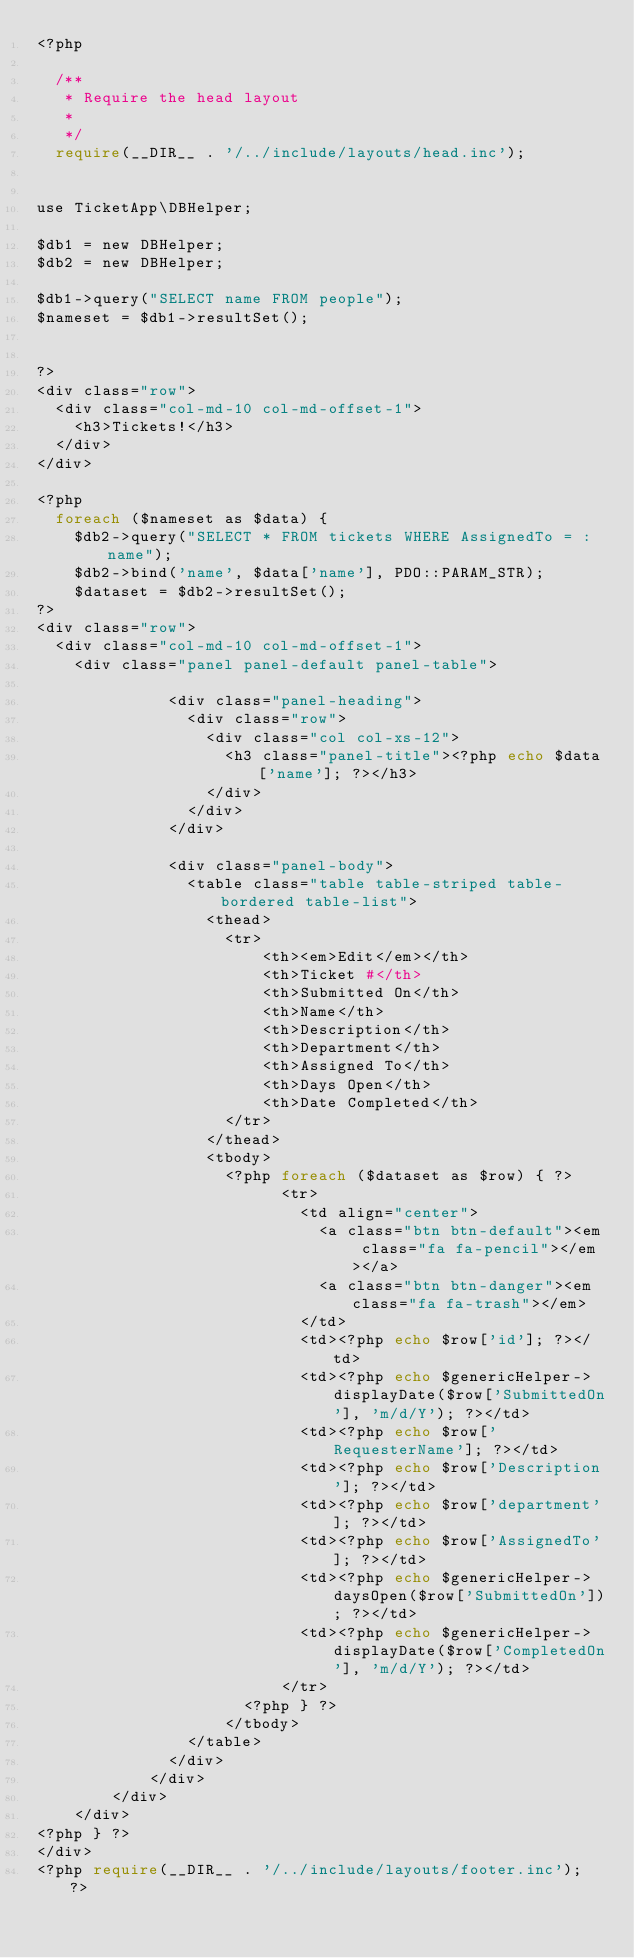Convert code to text. <code><loc_0><loc_0><loc_500><loc_500><_PHP_><?php

  /**
   * Require the head layout
   * 
   */
  require(__DIR__ . '/../include/layouts/head.inc');
  

use TicketApp\DBHelper;

$db1 = new DBHelper;
$db2 = new DBHelper;

$db1->query("SELECT name FROM people");
$nameset = $db1->resultSet();


?>
<div class="row">
  <div class="col-md-10 col-md-offset-1">
    <h3>Tickets!</h3>
  </div>
</div>

<?php
  foreach ($nameset as $data) {
    $db2->query("SELECT * FROM tickets WHERE AssignedTo = :name");
    $db2->bind('name', $data['name'], PDO::PARAM_STR);
    $dataset = $db2->resultSet();
?>
<div class="row">
  <div class="col-md-10 col-md-offset-1">
    <div class="panel panel-default panel-table">

              <div class="panel-heading">
                <div class="row">
                  <div class="col col-xs-12">
                    <h3 class="panel-title"><?php echo $data['name']; ?></h3>
                  </div>
                </div>
              </div>
              
              <div class="panel-body">
                <table class="table table-striped table-bordered table-list">
                  <thead>
                    <tr>
                        <th><em>Edit</em></th>
                        <th>Ticket #</th>
                        <th>Submitted On</th>
                        <th>Name</th>
                        <th>Description</th>
                        <th>Department</th>
                        <th>Assigned To</th>
                        <th>Days Open</th>
                        <th>Date Completed</th>
                    </tr> 
                  </thead>
                  <tbody>
                    <?php foreach ($dataset as $row) { ?>
                          <tr>
                            <td align="center">
                              <a class="btn btn-default"><em class="fa fa-pencil"></em></a>
                              <a class="btn btn-danger"><em class="fa fa-trash"></em>
                            </td>
                            <td><?php echo $row['id']; ?></td>
                            <td><?php echo $genericHelper->displayDate($row['SubmittedOn'], 'm/d/Y'); ?></td>
                            <td><?php echo $row['RequesterName']; ?></td>
                            <td><?php echo $row['Description']; ?></td>
                            <td><?php echo $row['department']; ?></td>
                            <td><?php echo $row['AssignedTo']; ?></td>
                            <td><?php echo $genericHelper->daysOpen($row['SubmittedOn']); ?></td>
                            <td><?php echo $genericHelper->displayDate($row['CompletedOn'], 'm/d/Y'); ?></td>
                          </tr>
                      <?php } ?>
                    </tbody>
                </table>
              </div>
            </div>
        </div>
    </div>
<?php } ?>
</div>
<?php require(__DIR__ . '/../include/layouts/footer.inc'); ?></code> 